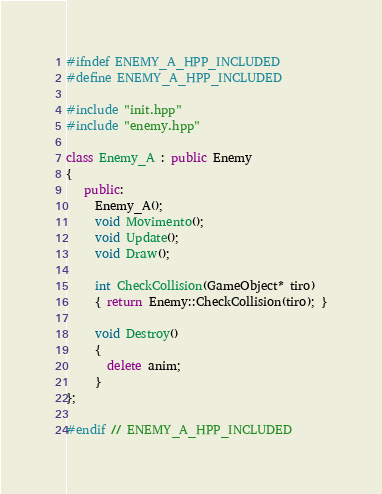Convert code to text. <code><loc_0><loc_0><loc_500><loc_500><_C++_>#ifndef ENEMY_A_HPP_INCLUDED
#define ENEMY_A_HPP_INCLUDED

#include "init.hpp"
#include "enemy.hpp"

class Enemy_A : public Enemy
{
   public:
     Enemy_A();
     void Movimento();
     void Update();
     void Draw();

     int CheckCollision(GameObject* tiro)
     { return Enemy::CheckCollision(tiro); }

     void Destroy()
     {
       delete anim;
     }
};

#endif // ENEMY_A_HPP_INCLUDED
</code> 